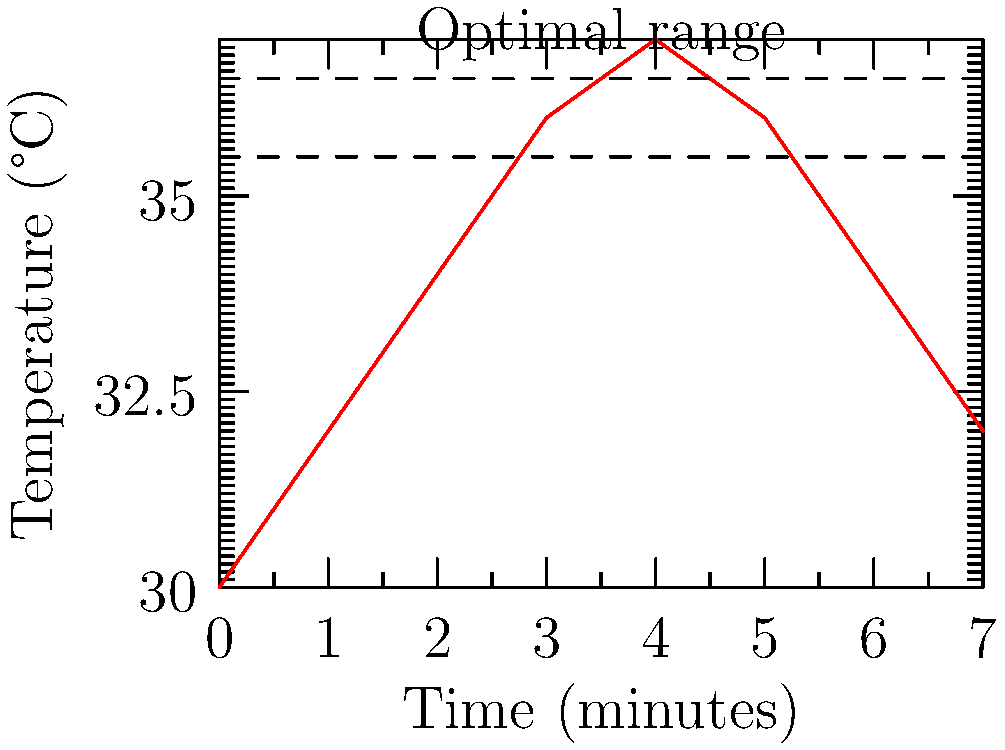The graph shows the temperature of breast milk over time after being warmed. The optimal temperature range for feeding is between 35.5°C and 36.5°C. For how many minutes is the milk within this optimal temperature range? To solve this problem, we need to follow these steps:

1. Identify the optimal temperature range on the graph:
   The range is marked by two dashed lines at 35.5°C and 36.5°C.

2. Find where the temperature line enters the optimal range:
   The line crosses the lower boundary (35.5°C) at approximately 1.5 minutes.

3. Find where the temperature line exits the optimal range:
   The line crosses the upper boundary (36.5°C) at approximately 4.5 minutes.

4. Calculate the time difference:
   $4.5 \text{ minutes} - 1.5 \text{ minutes} = 3 \text{ minutes}$

Therefore, the milk remains within the optimal temperature range for 3 minutes.
Answer: 3 minutes 